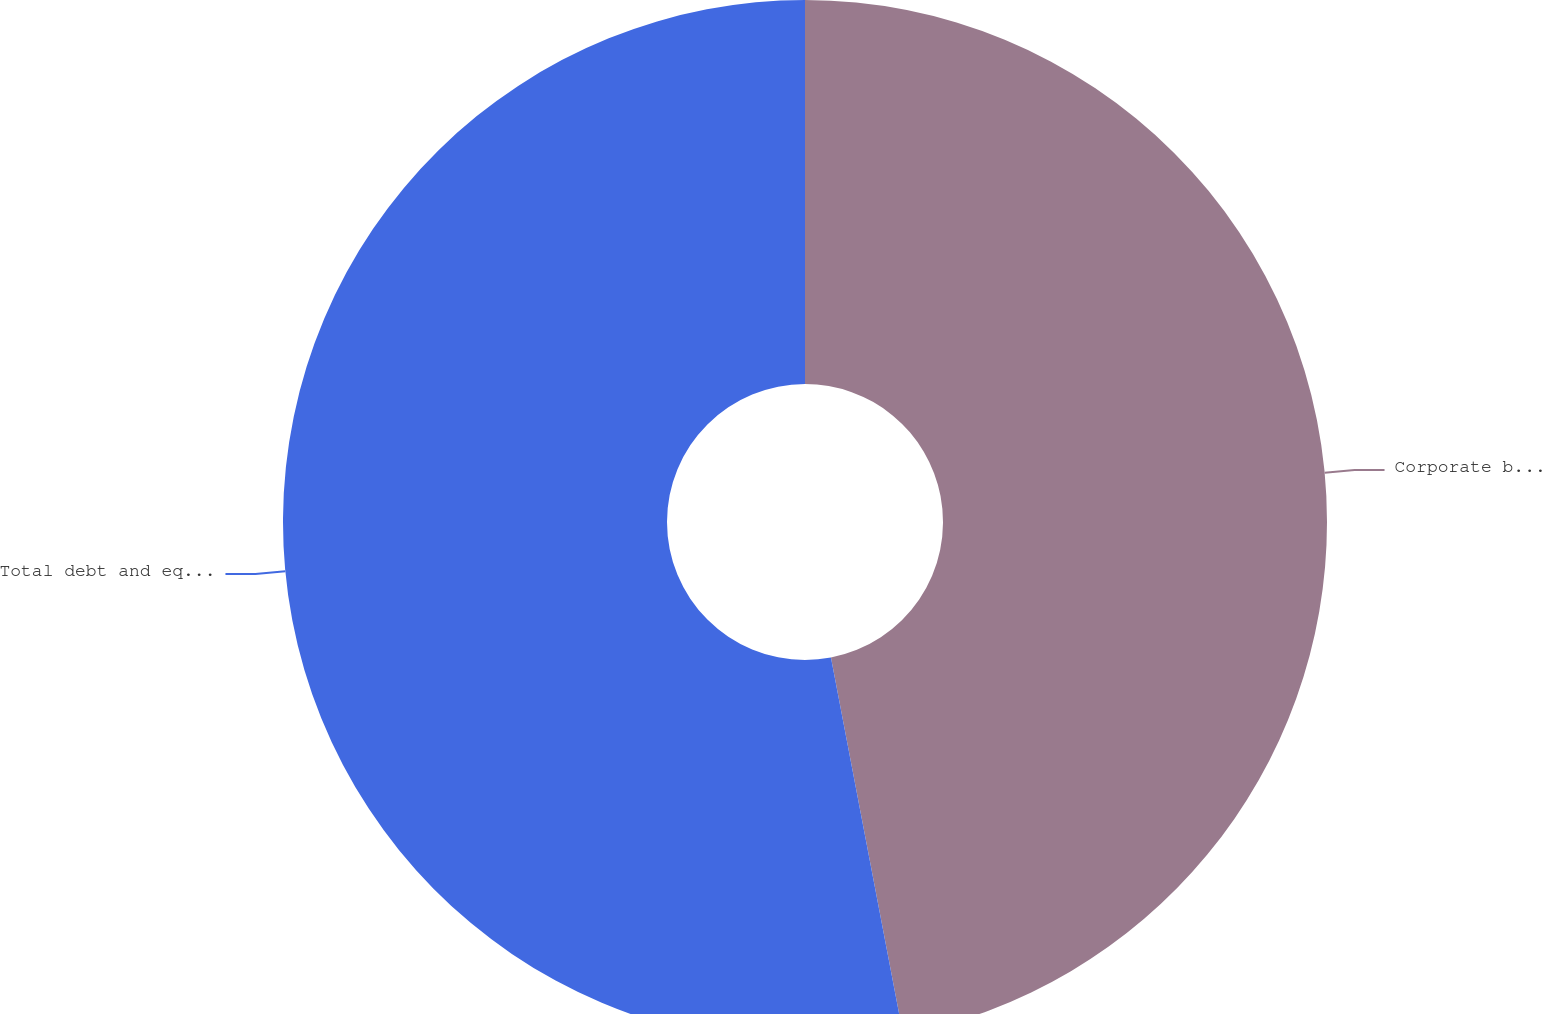Convert chart to OTSL. <chart><loc_0><loc_0><loc_500><loc_500><pie_chart><fcel>Corporate bonds<fcel>Total debt and equity<nl><fcel>46.99%<fcel>53.01%<nl></chart> 